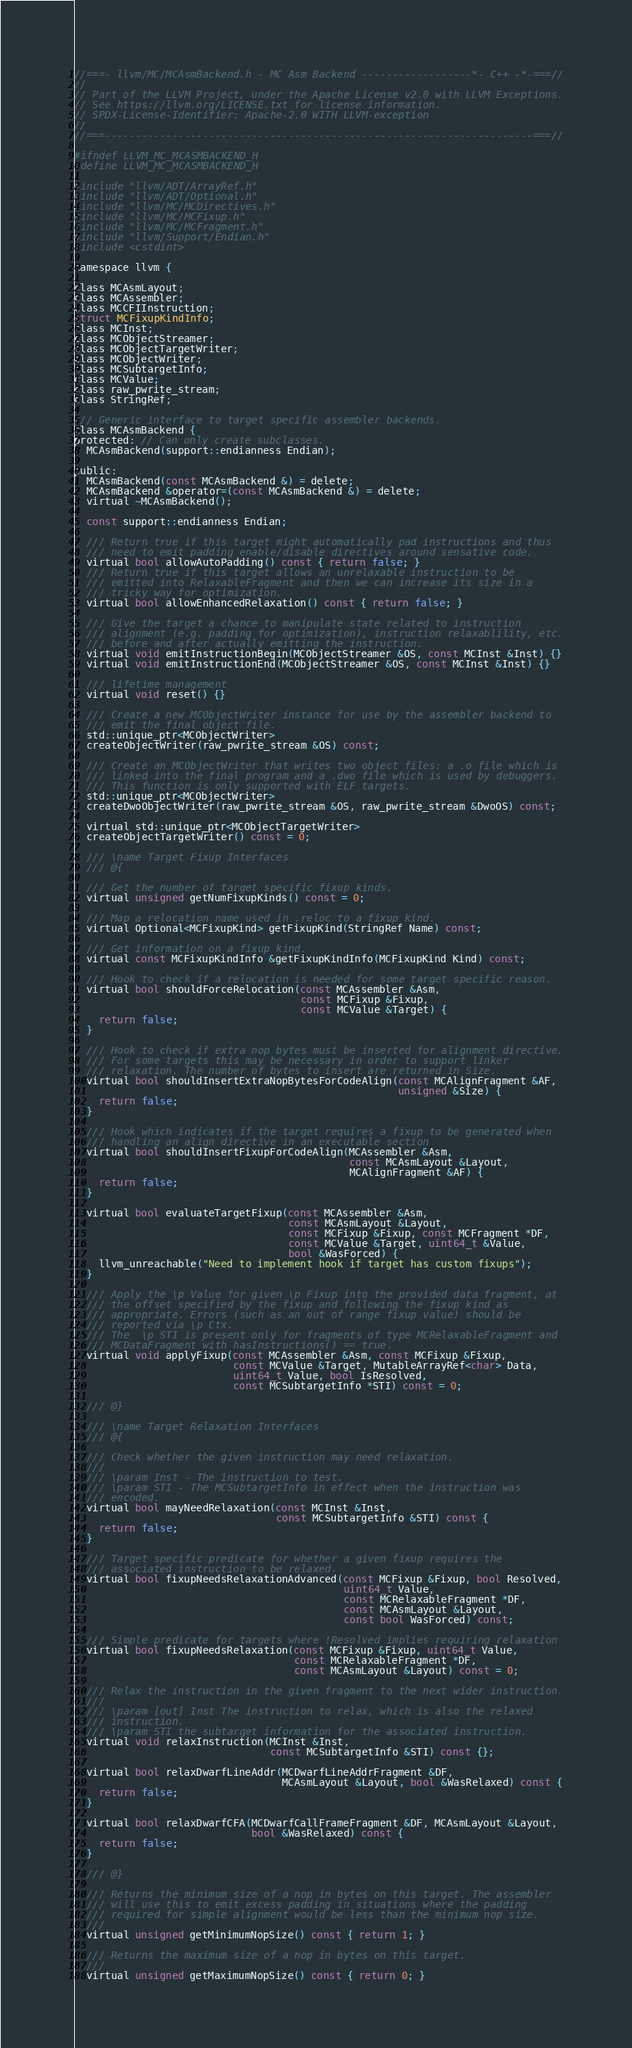Convert code to text. <code><loc_0><loc_0><loc_500><loc_500><_C_>//===- llvm/MC/MCAsmBackend.h - MC Asm Backend ------------------*- C++ -*-===//
//
// Part of the LLVM Project, under the Apache License v2.0 with LLVM Exceptions.
// See https://llvm.org/LICENSE.txt for license information.
// SPDX-License-Identifier: Apache-2.0 WITH LLVM-exception
//
//===----------------------------------------------------------------------===//

#ifndef LLVM_MC_MCASMBACKEND_H
#define LLVM_MC_MCASMBACKEND_H

#include "llvm/ADT/ArrayRef.h"
#include "llvm/ADT/Optional.h"
#include "llvm/MC/MCDirectives.h"
#include "llvm/MC/MCFixup.h"
#include "llvm/MC/MCFragment.h"
#include "llvm/Support/Endian.h"
#include <cstdint>

namespace llvm {

class MCAsmLayout;
class MCAssembler;
class MCCFIInstruction;
struct MCFixupKindInfo;
class MCInst;
class MCObjectStreamer;
class MCObjectTargetWriter;
class MCObjectWriter;
class MCSubtargetInfo;
class MCValue;
class raw_pwrite_stream;
class StringRef;

/// Generic interface to target specific assembler backends.
class MCAsmBackend {
protected: // Can only create subclasses.
  MCAsmBackend(support::endianness Endian);

public:
  MCAsmBackend(const MCAsmBackend &) = delete;
  MCAsmBackend &operator=(const MCAsmBackend &) = delete;
  virtual ~MCAsmBackend();

  const support::endianness Endian;

  /// Return true if this target might automatically pad instructions and thus
  /// need to emit padding enable/disable directives around sensative code.
  virtual bool allowAutoPadding() const { return false; }
  /// Return true if this target allows an unrelaxable instruction to be
  /// emitted into RelaxableFragment and then we can increase its size in a
  /// tricky way for optimization.
  virtual bool allowEnhancedRelaxation() const { return false; }

  /// Give the target a chance to manipulate state related to instruction
  /// alignment (e.g. padding for optimization), instruction relaxablility, etc.
  /// before and after actually emitting the instruction.
  virtual void emitInstructionBegin(MCObjectStreamer &OS, const MCInst &Inst) {}
  virtual void emitInstructionEnd(MCObjectStreamer &OS, const MCInst &Inst) {}

  /// lifetime management
  virtual void reset() {}

  /// Create a new MCObjectWriter instance for use by the assembler backend to
  /// emit the final object file.
  std::unique_ptr<MCObjectWriter>
  createObjectWriter(raw_pwrite_stream &OS) const;

  /// Create an MCObjectWriter that writes two object files: a .o file which is
  /// linked into the final program and a .dwo file which is used by debuggers.
  /// This function is only supported with ELF targets.
  std::unique_ptr<MCObjectWriter>
  createDwoObjectWriter(raw_pwrite_stream &OS, raw_pwrite_stream &DwoOS) const;

  virtual std::unique_ptr<MCObjectTargetWriter>
  createObjectTargetWriter() const = 0;

  /// \name Target Fixup Interfaces
  /// @{

  /// Get the number of target specific fixup kinds.
  virtual unsigned getNumFixupKinds() const = 0;

  /// Map a relocation name used in .reloc to a fixup kind.
  virtual Optional<MCFixupKind> getFixupKind(StringRef Name) const;

  /// Get information on a fixup kind.
  virtual const MCFixupKindInfo &getFixupKindInfo(MCFixupKind Kind) const;

  /// Hook to check if a relocation is needed for some target specific reason.
  virtual bool shouldForceRelocation(const MCAssembler &Asm,
                                     const MCFixup &Fixup,
                                     const MCValue &Target) {
    return false;
  }

  /// Hook to check if extra nop bytes must be inserted for alignment directive.
  /// For some targets this may be necessary in order to support linker
  /// relaxation. The number of bytes to insert are returned in Size.
  virtual bool shouldInsertExtraNopBytesForCodeAlign(const MCAlignFragment &AF,
                                                     unsigned &Size) {
    return false;
  }

  /// Hook which indicates if the target requires a fixup to be generated when
  /// handling an align directive in an executable section
  virtual bool shouldInsertFixupForCodeAlign(MCAssembler &Asm,
                                             const MCAsmLayout &Layout,
                                             MCAlignFragment &AF) {
    return false;
  }

  virtual bool evaluateTargetFixup(const MCAssembler &Asm,
                                   const MCAsmLayout &Layout,
                                   const MCFixup &Fixup, const MCFragment *DF,
                                   const MCValue &Target, uint64_t &Value,
                                   bool &WasForced) {
    llvm_unreachable("Need to implement hook if target has custom fixups");
  }

  /// Apply the \p Value for given \p Fixup into the provided data fragment, at
  /// the offset specified by the fixup and following the fixup kind as
  /// appropriate. Errors (such as an out of range fixup value) should be
  /// reported via \p Ctx.
  /// The  \p STI is present only for fragments of type MCRelaxableFragment and
  /// MCDataFragment with hasInstructions() == true.
  virtual void applyFixup(const MCAssembler &Asm, const MCFixup &Fixup,
                          const MCValue &Target, MutableArrayRef<char> Data,
                          uint64_t Value, bool IsResolved,
                          const MCSubtargetInfo *STI) const = 0;

  /// @}

  /// \name Target Relaxation Interfaces
  /// @{

  /// Check whether the given instruction may need relaxation.
  ///
  /// \param Inst - The instruction to test.
  /// \param STI - The MCSubtargetInfo in effect when the instruction was
  /// encoded.
  virtual bool mayNeedRelaxation(const MCInst &Inst,
                                 const MCSubtargetInfo &STI) const {
    return false;
  }

  /// Target specific predicate for whether a given fixup requires the
  /// associated instruction to be relaxed.
  virtual bool fixupNeedsRelaxationAdvanced(const MCFixup &Fixup, bool Resolved,
                                            uint64_t Value,
                                            const MCRelaxableFragment *DF,
                                            const MCAsmLayout &Layout,
                                            const bool WasForced) const;

  /// Simple predicate for targets where !Resolved implies requiring relaxation
  virtual bool fixupNeedsRelaxation(const MCFixup &Fixup, uint64_t Value,
                                    const MCRelaxableFragment *DF,
                                    const MCAsmLayout &Layout) const = 0;

  /// Relax the instruction in the given fragment to the next wider instruction.
  ///
  /// \param [out] Inst The instruction to relax, which is also the relaxed
  /// instruction.
  /// \param STI the subtarget information for the associated instruction.
  virtual void relaxInstruction(MCInst &Inst,
                                const MCSubtargetInfo &STI) const {};

  virtual bool relaxDwarfLineAddr(MCDwarfLineAddrFragment &DF,
                                  MCAsmLayout &Layout, bool &WasRelaxed) const {
    return false;
  }

  virtual bool relaxDwarfCFA(MCDwarfCallFrameFragment &DF, MCAsmLayout &Layout,
                             bool &WasRelaxed) const {
    return false;
  }

  /// @}

  /// Returns the minimum size of a nop in bytes on this target. The assembler
  /// will use this to emit excess padding in situations where the padding
  /// required for simple alignment would be less than the minimum nop size.
  ///
  virtual unsigned getMinimumNopSize() const { return 1; }

  /// Returns the maximum size of a nop in bytes on this target.
  ///
  virtual unsigned getMaximumNopSize() const { return 0; }
</code> 